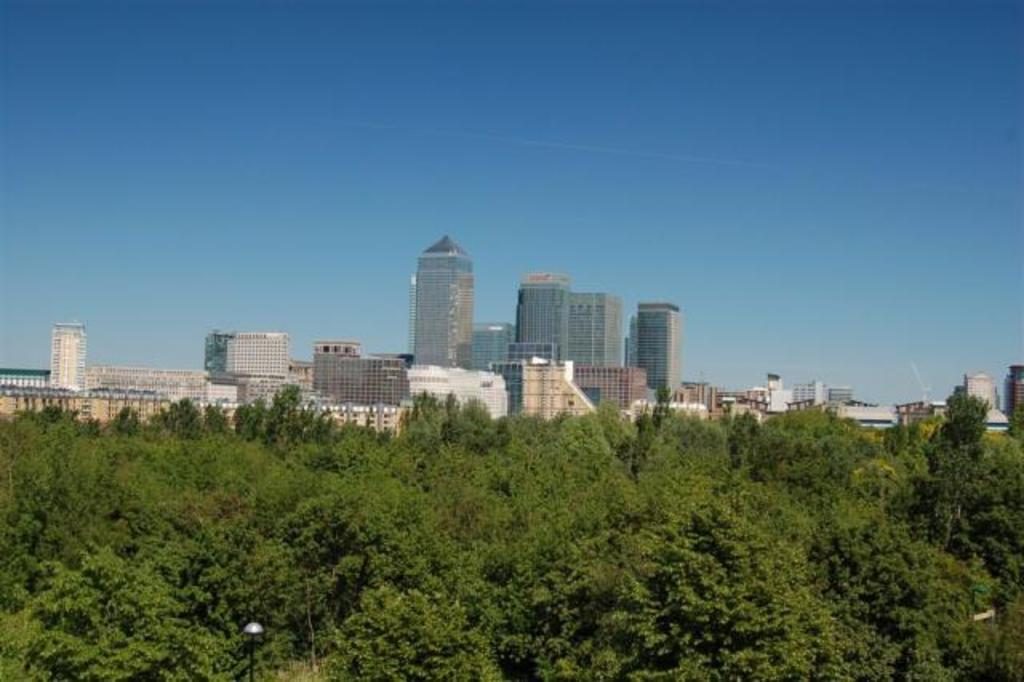What type of natural elements can be seen in the image? There are trees in the image. What man-made structures are present in the image? There are poles and buildings in the image. What part of the natural environment is visible in the image? The sky is visible in the background of the image. What territory does the image represent? The image does not represent any specific territory; it simply shows trees, poles, buildings, and the sky. How does the image convey a sense of hate? The image does not convey any emotions, including hate, as it is a static representation of the environment. 